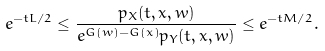<formula> <loc_0><loc_0><loc_500><loc_500>e ^ { - t L / 2 } \leq \frac { p _ { X } ( t , x , w ) } { e ^ { G ( w ) - G ( x ) } p _ { Y } ( t , x , w ) } \leq e ^ { - t M / 2 } .</formula> 